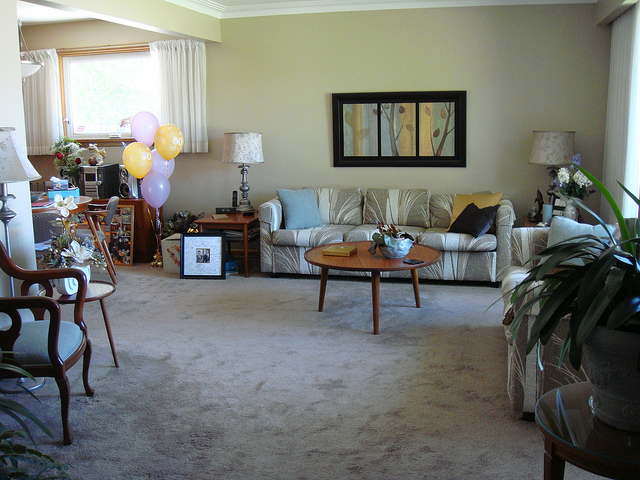<image>What type of activity goes on at the tables? It is ambiguous as to what activity goes on at the tables. It could be drinks, sitting, snacking, afternoon tea, reading, a party, watching tv or eating. What type of activity goes on at the tables? I am not sure what type of activity goes on at the tables. It can be drinks, sitting, snacking, afternoon tea, reading, party, TV, or eating. 